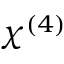Convert formula to latex. <formula><loc_0><loc_0><loc_500><loc_500>\chi ^ { ( 4 ) }</formula> 